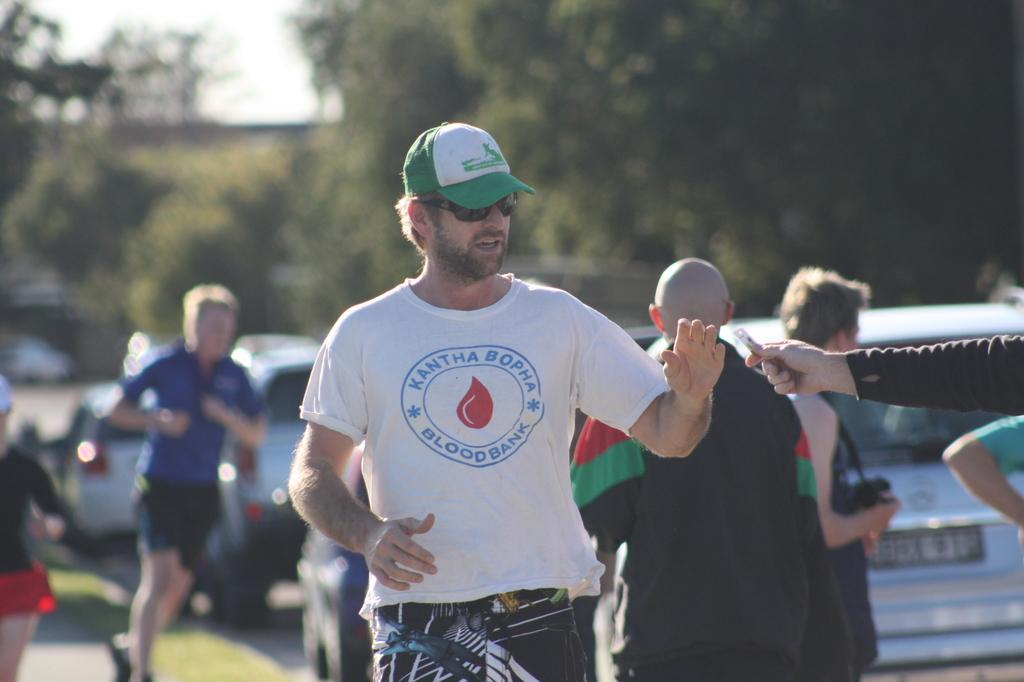What is the person in the image wearing? The person in the image is wearing a hat and spectacles. What is the person in the image doing? The person is standing. What can be seen in the background of the image? There is a group of people, vehicles parked on a path, trees, and the sky visible in the background of the image. What type of range can be seen in the image? There is no range present in the image. Is the person in the image using a swing? There is no swing present in the image. 